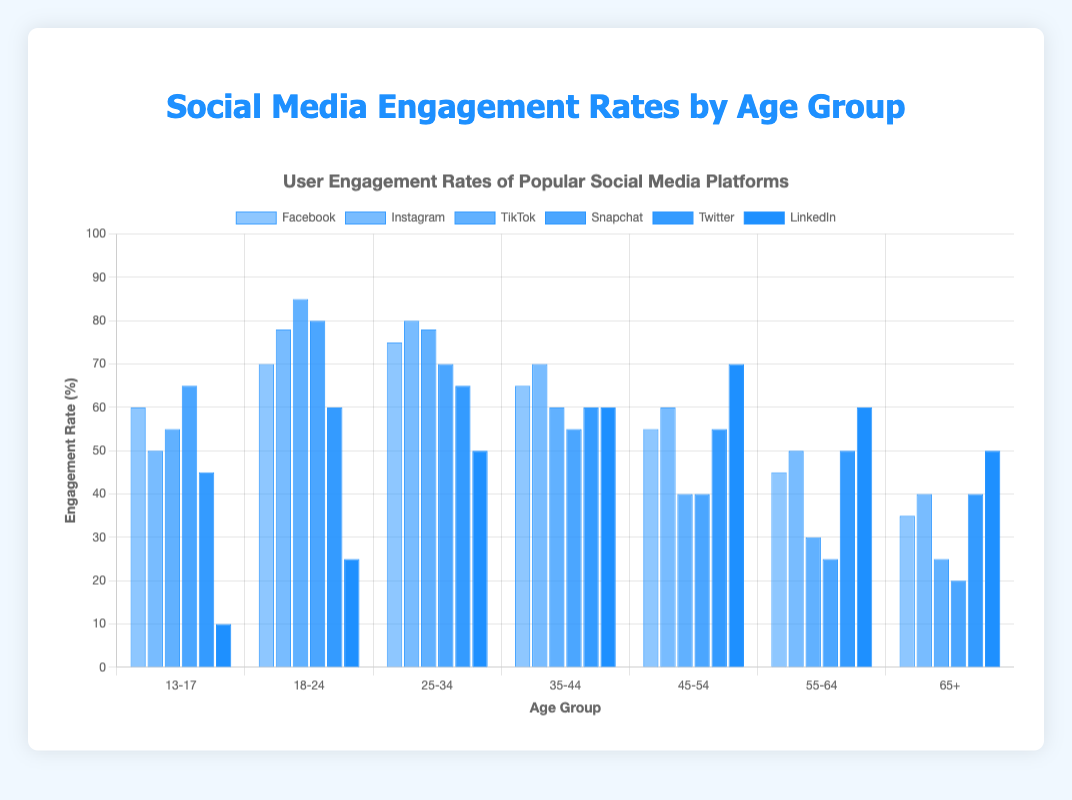Which age group has the highest engagement rate on Instagram? Observe the height of the bars for each age group under the label "Instagram." The tallest bar represents the 18-24 age group.
Answer: 18-24 Which social media platform has the lowest engagement rate among the 65+ age group? Compare the heights of all the blue bars for the "65+" age group. The shortest bar is for TikTok at 25%.
Answer: TikTok What's the difference in engagement rates between Snapchat and LinkedIn among the 25-34 age group? Find the heights of the blue bars representing Snapchat and LinkedIn for the 25-34 age group. Subtract the engagement rate of LinkedIn (50%) from Snapchat (70%). 70% - 50% = 20%
Answer: 20% Which age group has the lowest engagement rate on Facebook, and what is that rate? Observe the height of the bars for each age group under the label "Facebook." The shortest bar represents the 65+ age group with an engagement rate of 35%.
Answer: 65+, 35% Which two age groups have the highest average engagement rate on TikTok? Calculate the average engagement rate for each age group and find the highest two. The 18-24 and 13-17 age groups have the highest engagement rates on TikTok at 85% and 55%, respectively.
Answer: 18-24, 13-17 Among the 45-54 age group, which social media platform has the most equal engagement rate compared to Twitter? Compare the engagement rates of other platforms with Twitter's 55%. Facebook matches Twitter at 55%.
Answer: Facebook Which platform shows the most significant engagement rate drop from the 18-24 age group to the 25-34 age group? Calculate the difference in engagement rates between 18-24 and 25-34 for each platform. TikTok drops from 85% to 78%, a difference of 7%. This is the highest drop.
Answer: TikTok What is the total engagement rate of Facebook across all age groups? Sum the engagement rates of Facebook for all the age groups: 60 + 70 + 75 + 65 + 55 + 45 + 35 = 405.
Answer: 405% For the 35-44 age group, which platform has fewer engagement rates than Instagram? Compare the engagement rate bars for the 35-44 age group under the label "Instagram" (70%) with other platforms. Both TikTok (60%) and Snapchat (55%) have fewer engagement rates.
Answer: TikTok, Snapchat What's the average engagement rate of LinkedIn across the 35-44, 45-54, and 55-64 age groups? Calculate the average of the engagement rates of LinkedIn for these age groups: (60 + 70 + 60) / 3 = 63.33%.
Answer: 63.33% 